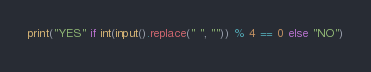<code> <loc_0><loc_0><loc_500><loc_500><_Python_>print("YES" if int(input().replace(" ", "")) % 4 == 0 else "NO")</code> 